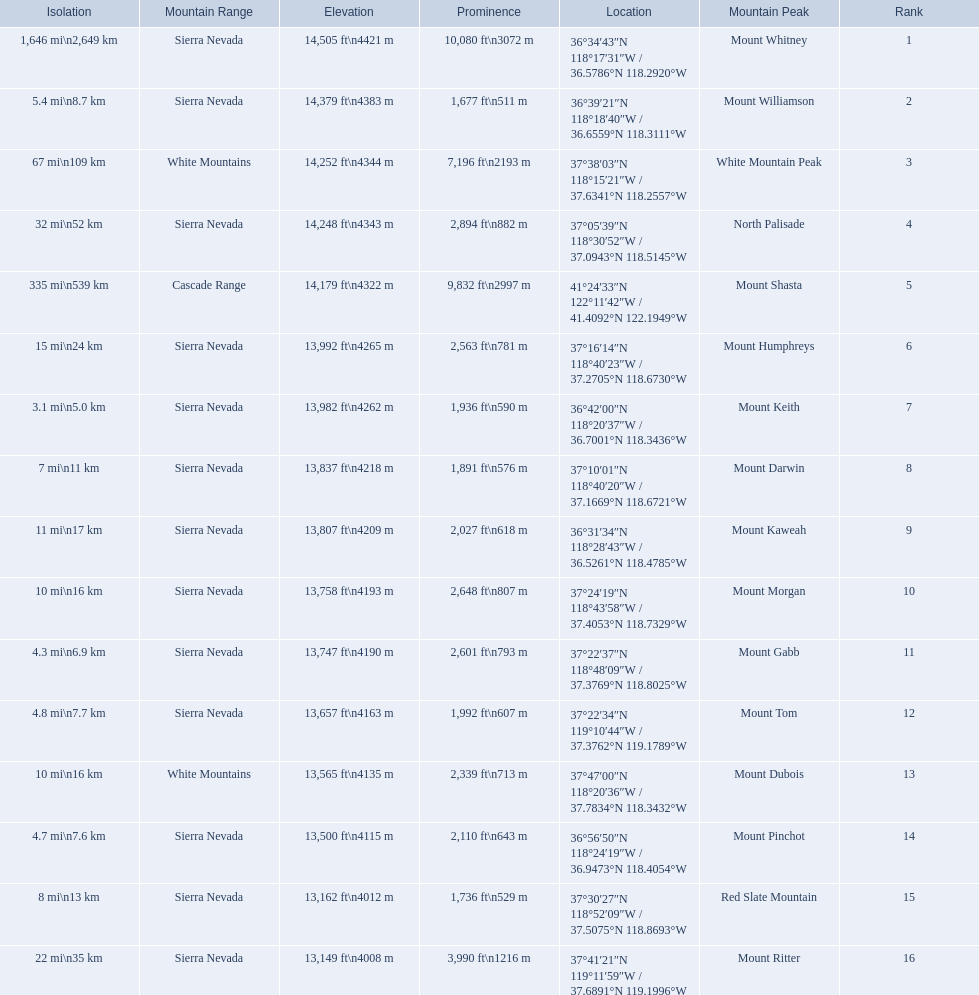Which mountain peaks have a prominence over 9,000 ft? Mount Whitney, Mount Shasta. Of those, which one has the the highest prominence? Mount Whitney. 